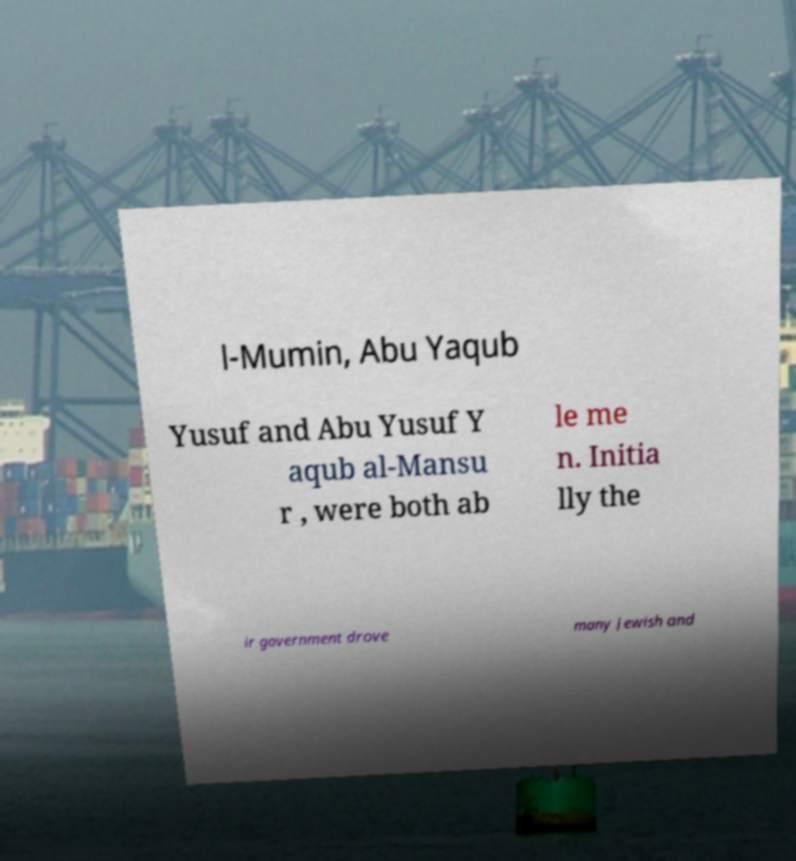There's text embedded in this image that I need extracted. Can you transcribe it verbatim? l-Mumin, Abu Yaqub Yusuf and Abu Yusuf Y aqub al-Mansu r , were both ab le me n. Initia lly the ir government drove many Jewish and 